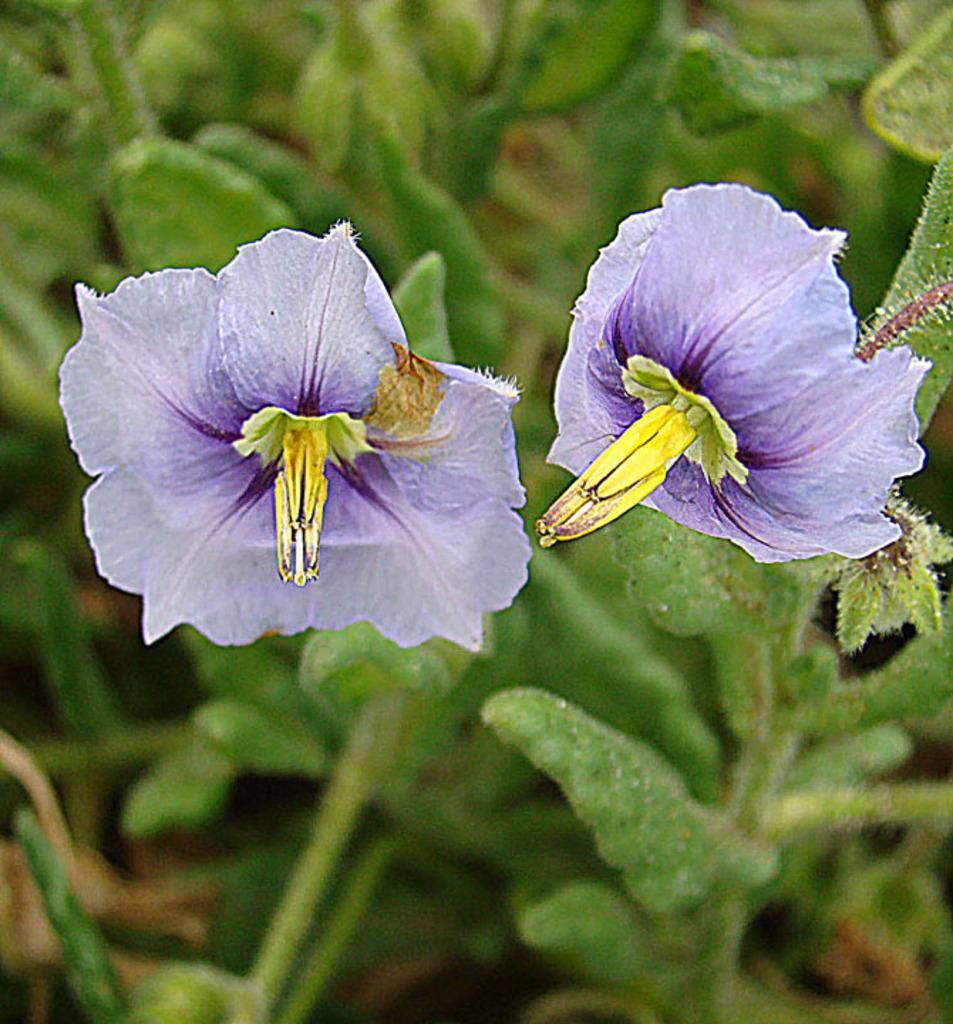Describe this image in one or two sentences. In this image I can see a purple and yellow color flower. I can see green color leaves. 